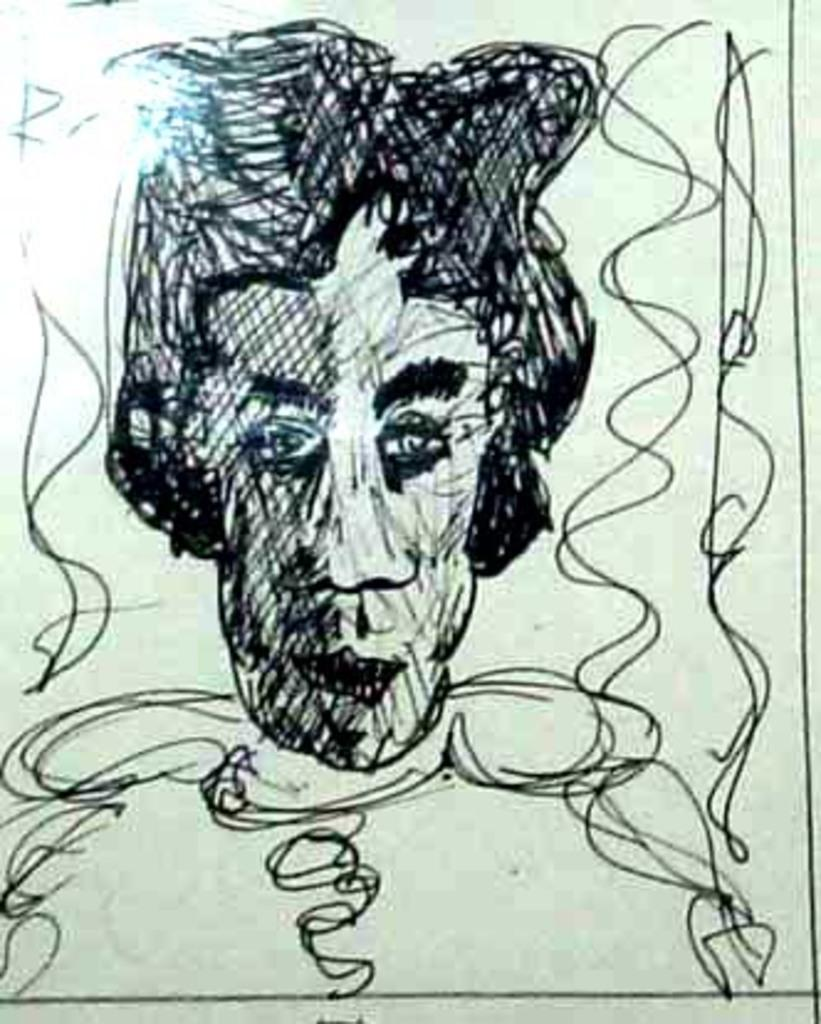What is depicted on the white surface in the image? There is a sketch on a white surface, and it is of a person. What color is the sketch? The sketch is in black color. Where is the light source located in the image? The light is on the left side of the image. How many arms does the person in the sketch have? The sketch is in black and white, and it is not possible to determine the number of arms the person has based on the image. 